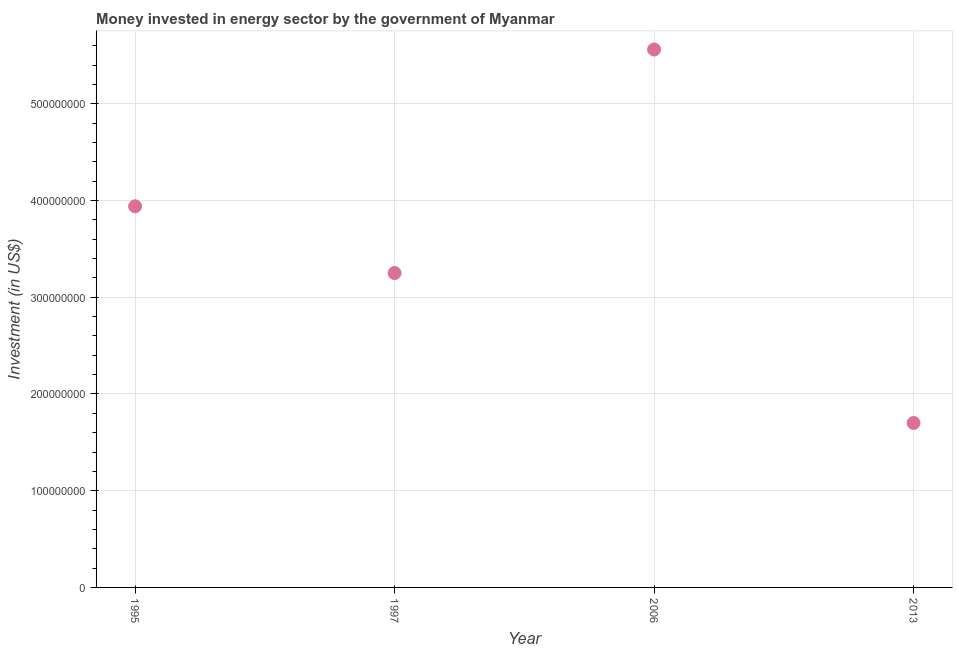What is the investment in energy in 2006?
Your answer should be very brief. 5.56e+08. Across all years, what is the maximum investment in energy?
Make the answer very short. 5.56e+08. Across all years, what is the minimum investment in energy?
Provide a succinct answer. 1.70e+08. In which year was the investment in energy maximum?
Give a very brief answer. 2006. In which year was the investment in energy minimum?
Make the answer very short. 2013. What is the sum of the investment in energy?
Your answer should be compact. 1.45e+09. What is the difference between the investment in energy in 2006 and 2013?
Give a very brief answer. 3.86e+08. What is the average investment in energy per year?
Your response must be concise. 3.61e+08. What is the median investment in energy?
Provide a short and direct response. 3.60e+08. In how many years, is the investment in energy greater than 500000000 US$?
Your response must be concise. 1. What is the ratio of the investment in energy in 1997 to that in 2006?
Give a very brief answer. 0.58. Is the investment in energy in 1995 less than that in 2013?
Your answer should be compact. No. Is the difference between the investment in energy in 1997 and 2006 greater than the difference between any two years?
Your answer should be compact. No. What is the difference between the highest and the second highest investment in energy?
Provide a succinct answer. 1.62e+08. Is the sum of the investment in energy in 1997 and 2006 greater than the maximum investment in energy across all years?
Offer a terse response. Yes. What is the difference between the highest and the lowest investment in energy?
Provide a short and direct response. 3.86e+08. How many years are there in the graph?
Provide a short and direct response. 4. Are the values on the major ticks of Y-axis written in scientific E-notation?
Offer a terse response. No. Does the graph contain any zero values?
Keep it short and to the point. No. What is the title of the graph?
Your response must be concise. Money invested in energy sector by the government of Myanmar. What is the label or title of the X-axis?
Provide a succinct answer. Year. What is the label or title of the Y-axis?
Offer a very short reply. Investment (in US$). What is the Investment (in US$) in 1995?
Offer a terse response. 3.94e+08. What is the Investment (in US$) in 1997?
Keep it short and to the point. 3.25e+08. What is the Investment (in US$) in 2006?
Offer a terse response. 5.56e+08. What is the Investment (in US$) in 2013?
Ensure brevity in your answer.  1.70e+08. What is the difference between the Investment (in US$) in 1995 and 1997?
Keep it short and to the point. 6.90e+07. What is the difference between the Investment (in US$) in 1995 and 2006?
Provide a short and direct response. -1.62e+08. What is the difference between the Investment (in US$) in 1995 and 2013?
Your answer should be very brief. 2.24e+08. What is the difference between the Investment (in US$) in 1997 and 2006?
Offer a very short reply. -2.31e+08. What is the difference between the Investment (in US$) in 1997 and 2013?
Ensure brevity in your answer.  1.55e+08. What is the difference between the Investment (in US$) in 2006 and 2013?
Keep it short and to the point. 3.86e+08. What is the ratio of the Investment (in US$) in 1995 to that in 1997?
Ensure brevity in your answer.  1.21. What is the ratio of the Investment (in US$) in 1995 to that in 2006?
Your response must be concise. 0.71. What is the ratio of the Investment (in US$) in 1995 to that in 2013?
Provide a succinct answer. 2.32. What is the ratio of the Investment (in US$) in 1997 to that in 2006?
Ensure brevity in your answer.  0.58. What is the ratio of the Investment (in US$) in 1997 to that in 2013?
Keep it short and to the point. 1.91. What is the ratio of the Investment (in US$) in 2006 to that in 2013?
Give a very brief answer. 3.27. 